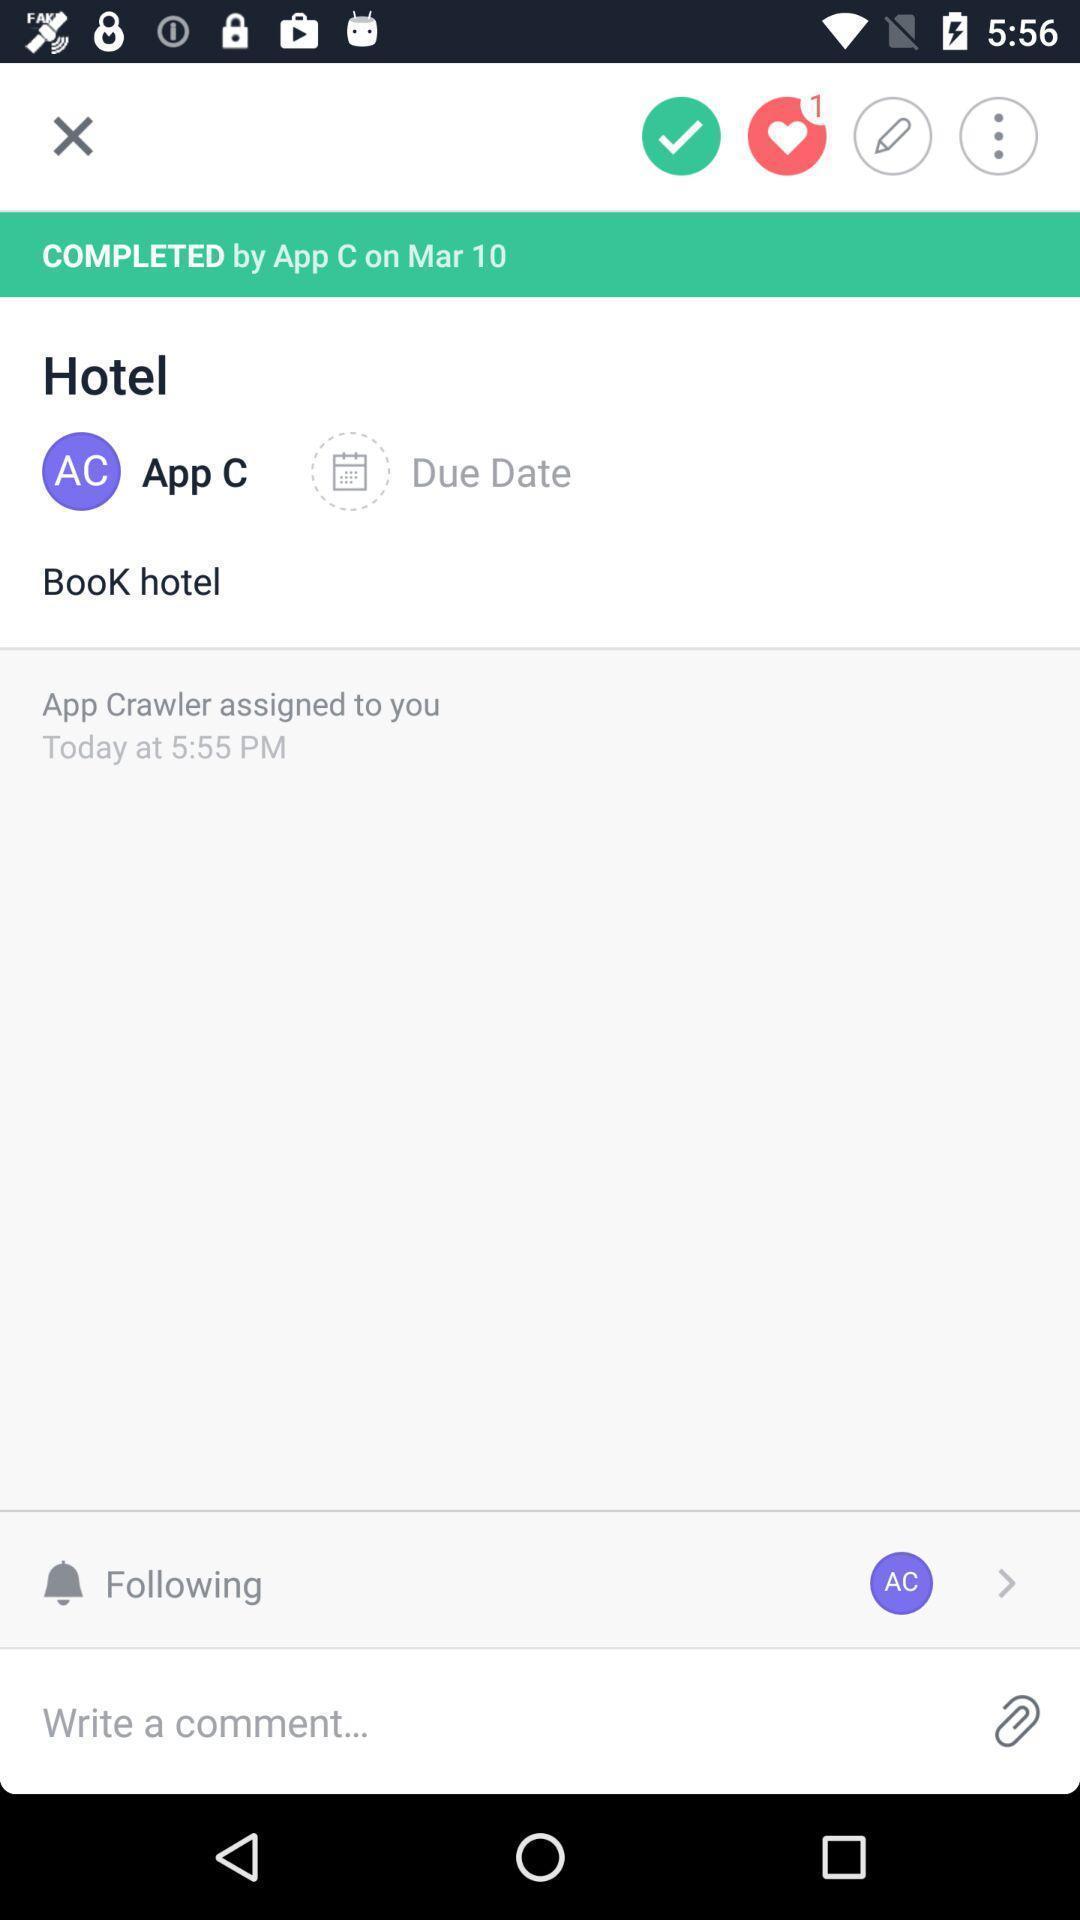What details can you identify in this image? Screen shows to book a hotel. 